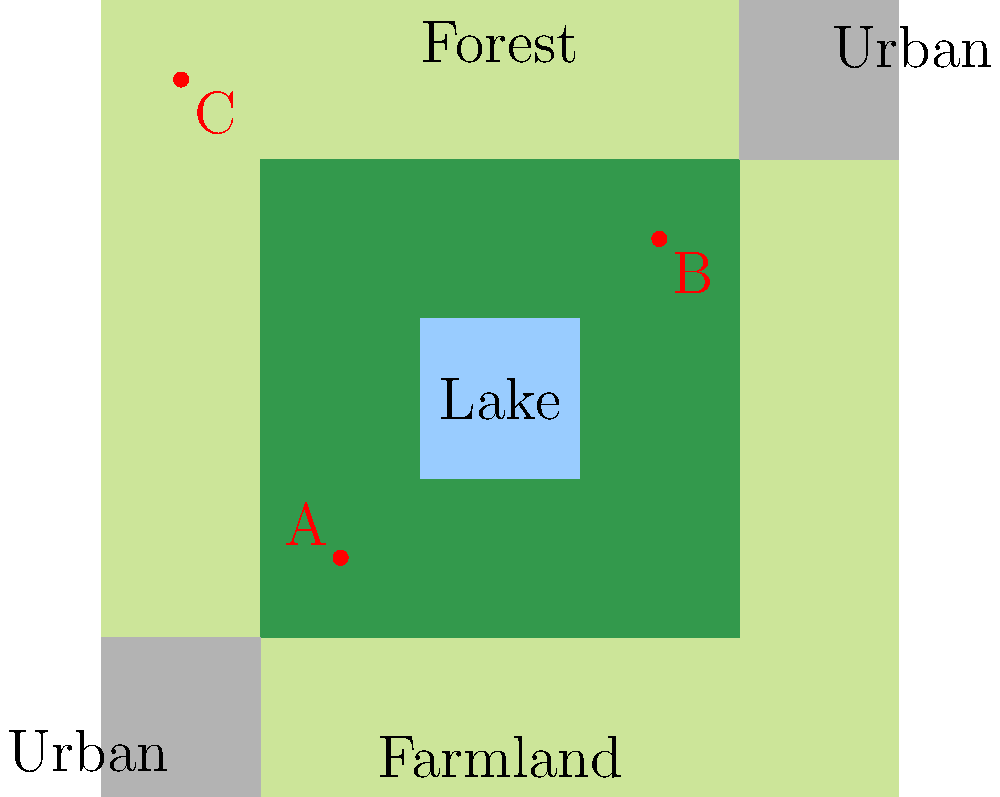Based on the land use map shown, which location (A, B, or C) would be the most suitable for an agri-tourism facility that aims to showcase sustainable farming practices while minimizing environmental impact? To determine the most suitable location for an agri-tourism facility that showcases sustainable farming practices while minimizing environmental impact, we need to consider several factors:

1. Proximity to farmland: The facility should be close to agricultural areas to demonstrate farming practices.
2. Access to natural resources: Nearby forests and water bodies can enhance the educational experience and recreational opportunities.
3. Distance from urban areas: A balance between accessibility and preserving rural character is important.
4. Minimal impact on existing ecosystems: Avoid disrupting large forested areas or water bodies.

Let's analyze each location:

A. Located at the edge of the forest, close to farmland and the lake. It provides access to diverse ecosystems without being in the center of any sensitive area.

B. Situated between farmland and forest, close to an urban area. While it offers access to different land types, it's closer to urban development, which may impact the rural experience.

C. Located in a corner of farmland, far from the forest and lake. It lacks diversity in nearby ecosystems and is distant from natural resources.

Considering these factors, location A appears to be the most suitable because:
1. It's adjacent to farmland, allowing for demonstrations of sustainable farming practices.
2. It's close to both forest and water resources, providing opportunities for diverse educational experiences.
3. It's sufficiently distant from urban areas to maintain a rural atmosphere.
4. It minimizes impact on existing ecosystems by being at the edge of the forest rather than in its center.
Answer: A 